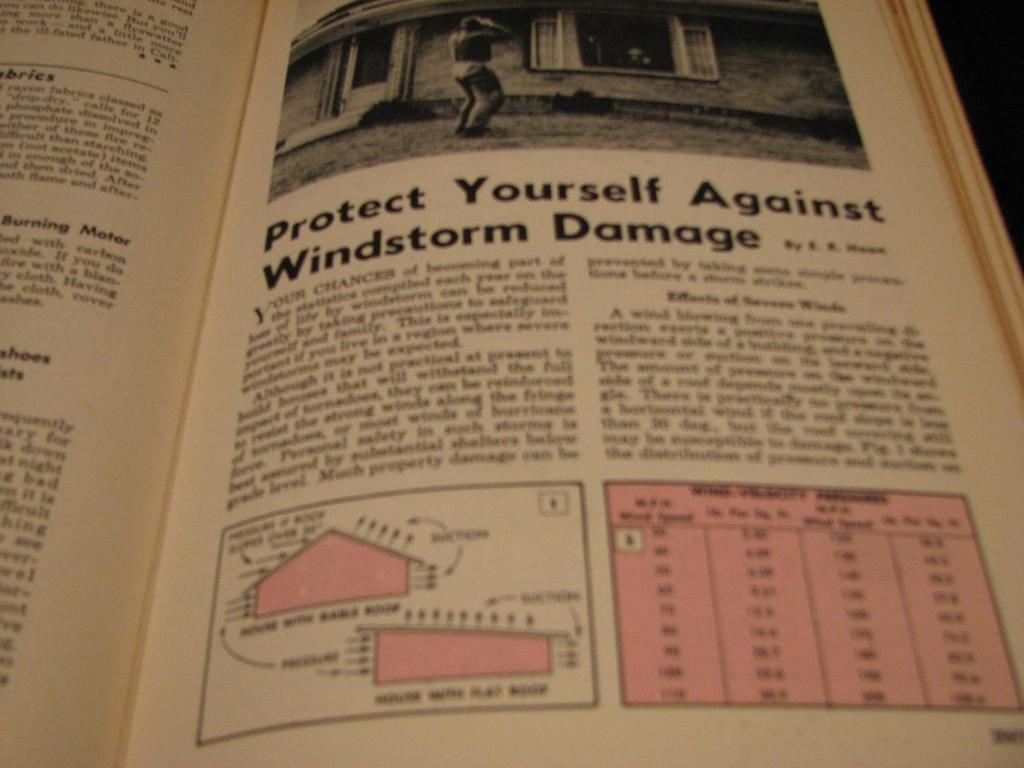What should you protect yourself against?
Your answer should be very brief. Windstorm damage. 